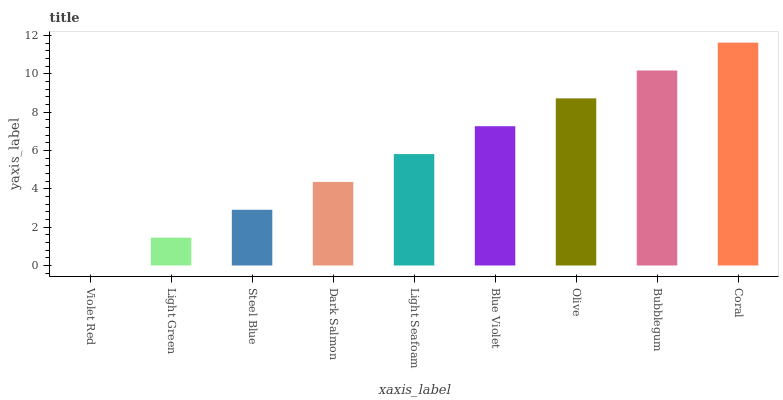Is Violet Red the minimum?
Answer yes or no. Yes. Is Coral the maximum?
Answer yes or no. Yes. Is Light Green the minimum?
Answer yes or no. No. Is Light Green the maximum?
Answer yes or no. No. Is Light Green greater than Violet Red?
Answer yes or no. Yes. Is Violet Red less than Light Green?
Answer yes or no. Yes. Is Violet Red greater than Light Green?
Answer yes or no. No. Is Light Green less than Violet Red?
Answer yes or no. No. Is Light Seafoam the high median?
Answer yes or no. Yes. Is Light Seafoam the low median?
Answer yes or no. Yes. Is Coral the high median?
Answer yes or no. No. Is Light Green the low median?
Answer yes or no. No. 